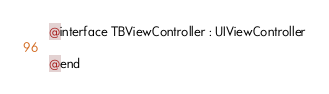Convert code to text. <code><loc_0><loc_0><loc_500><loc_500><_C_>@interface TBViewController : UIViewController

@end
</code> 